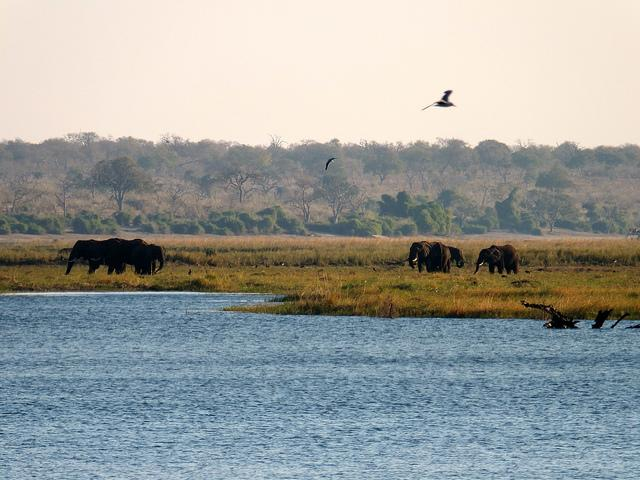Besides Africa what continent can these animals be found naturally on? Please explain your reasoning. asia. Asia is another continent. 